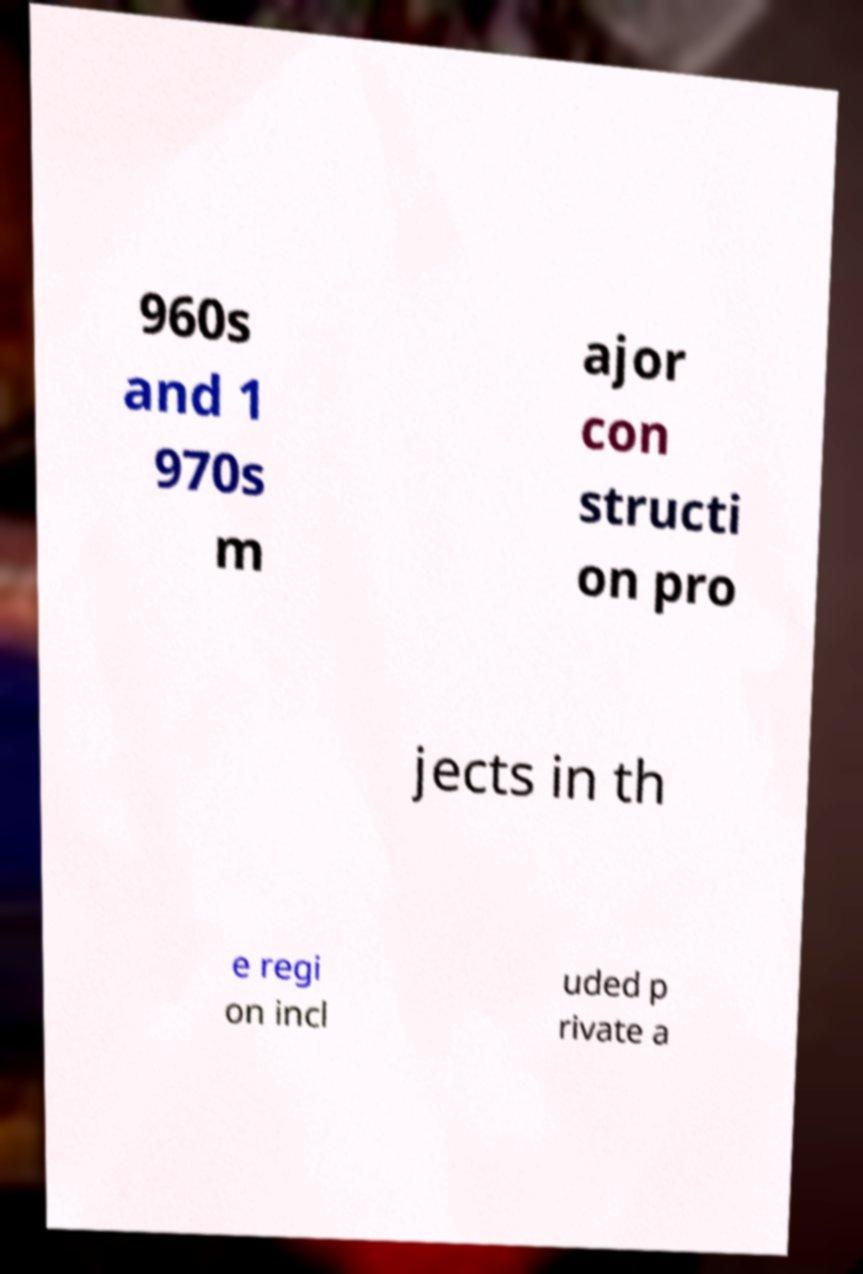Please identify and transcribe the text found in this image. 960s and 1 970s m ajor con structi on pro jects in th e regi on incl uded p rivate a 